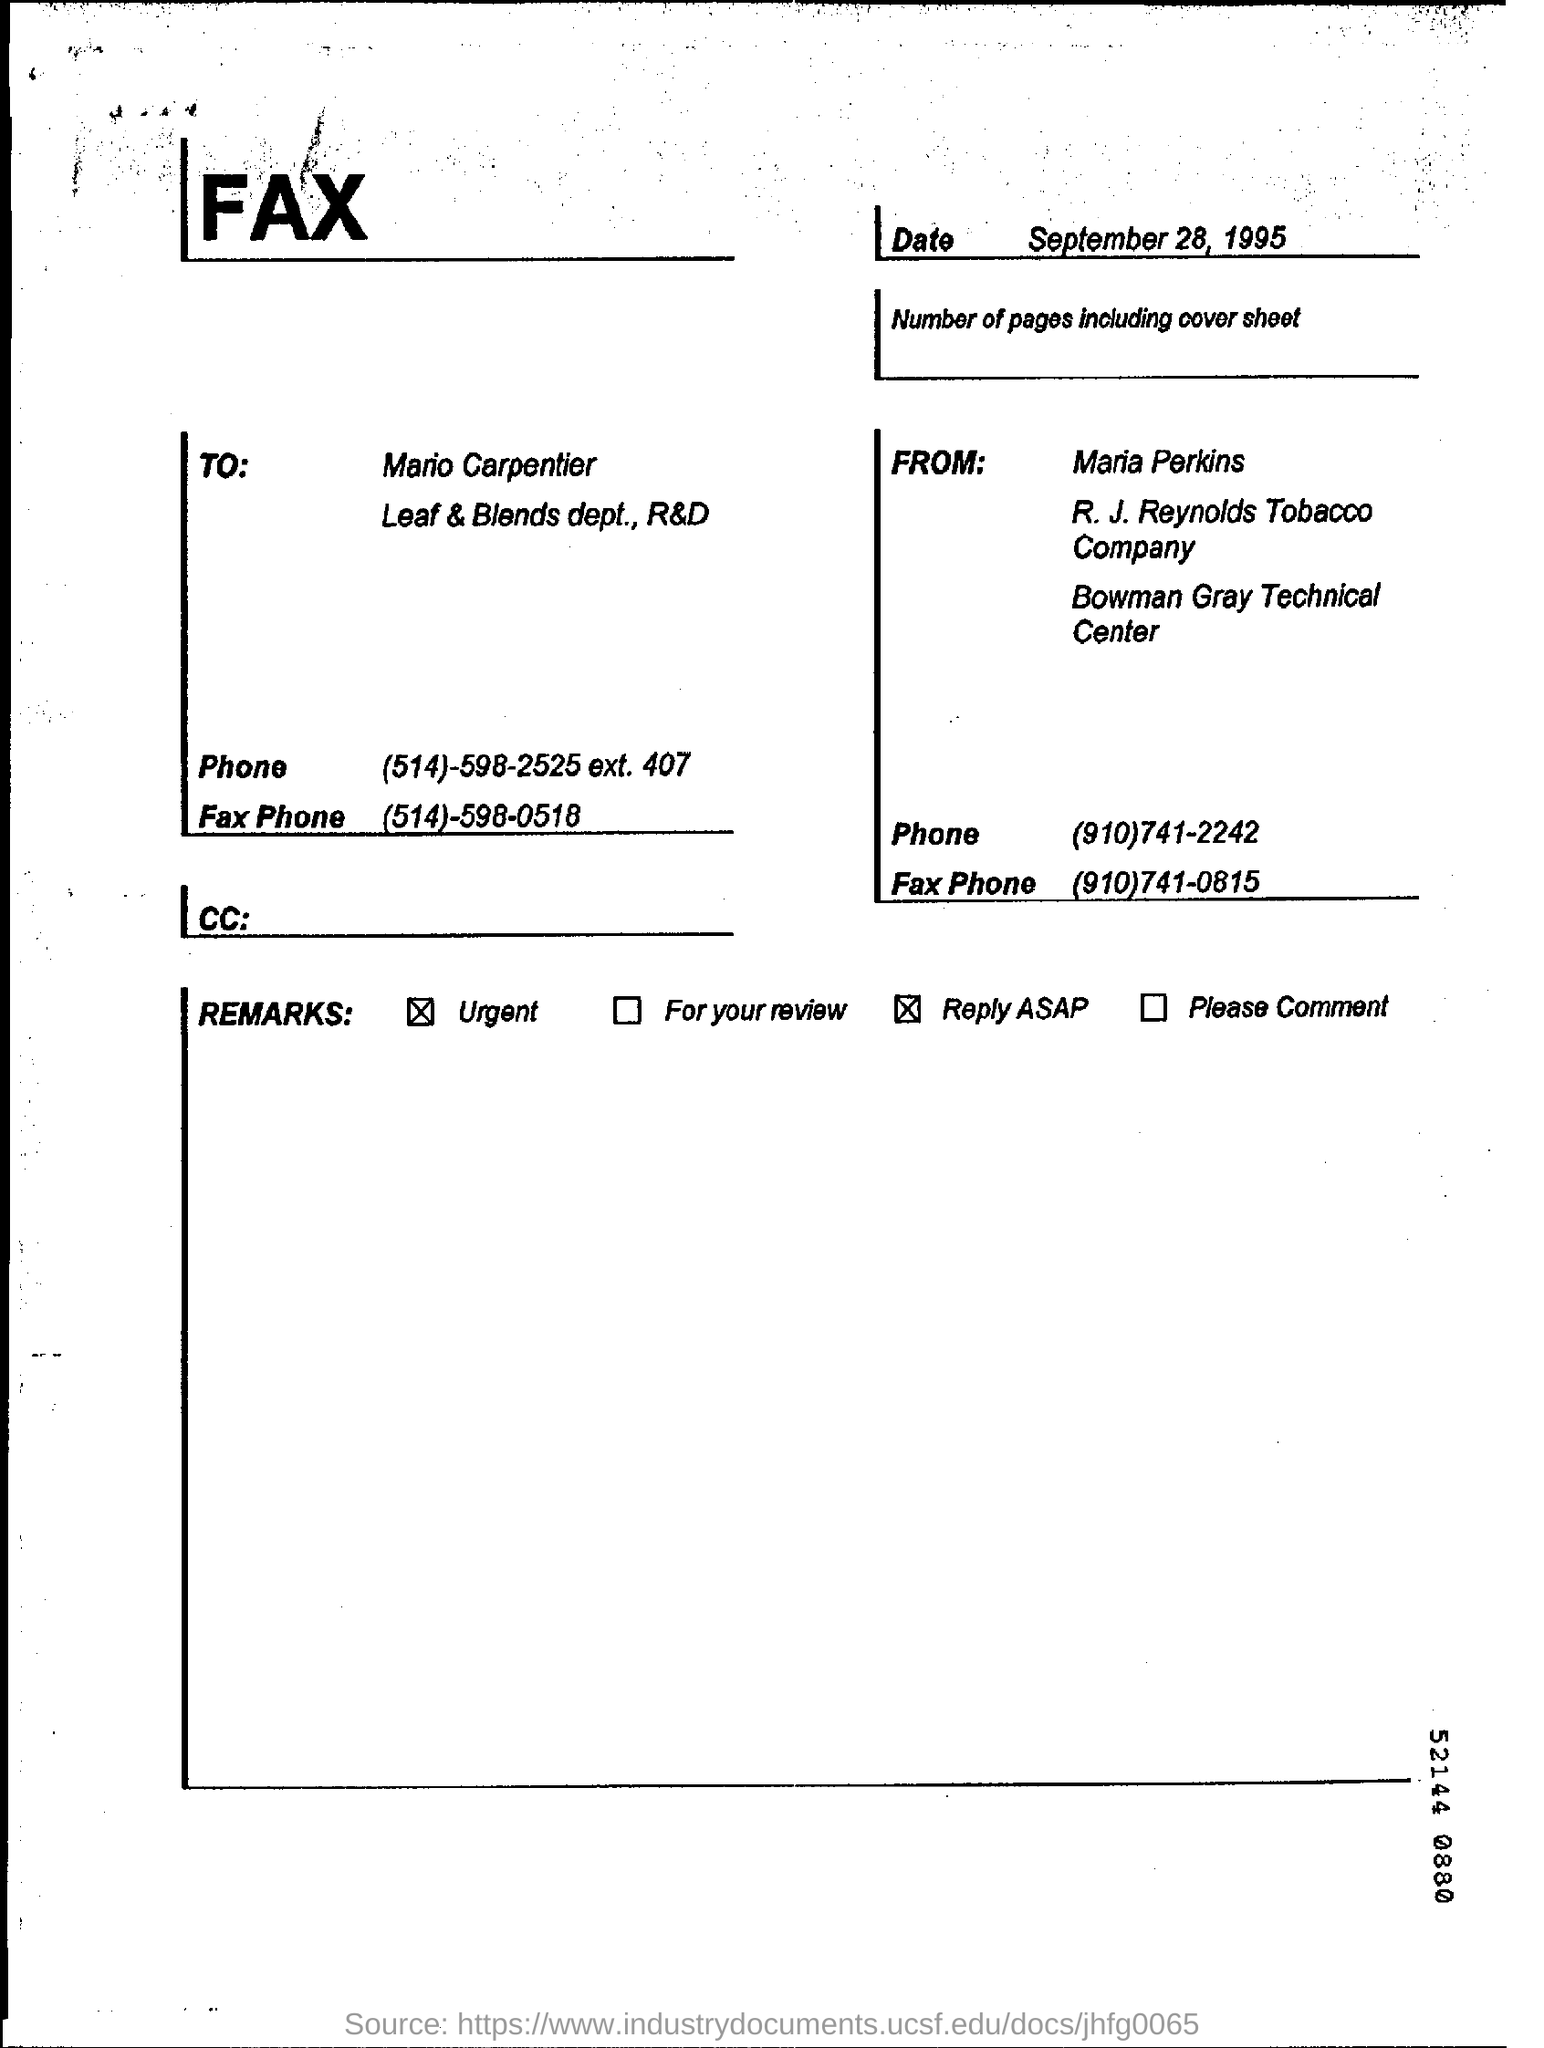Identify some key points in this picture. The date of the document is September 28, 1995. 